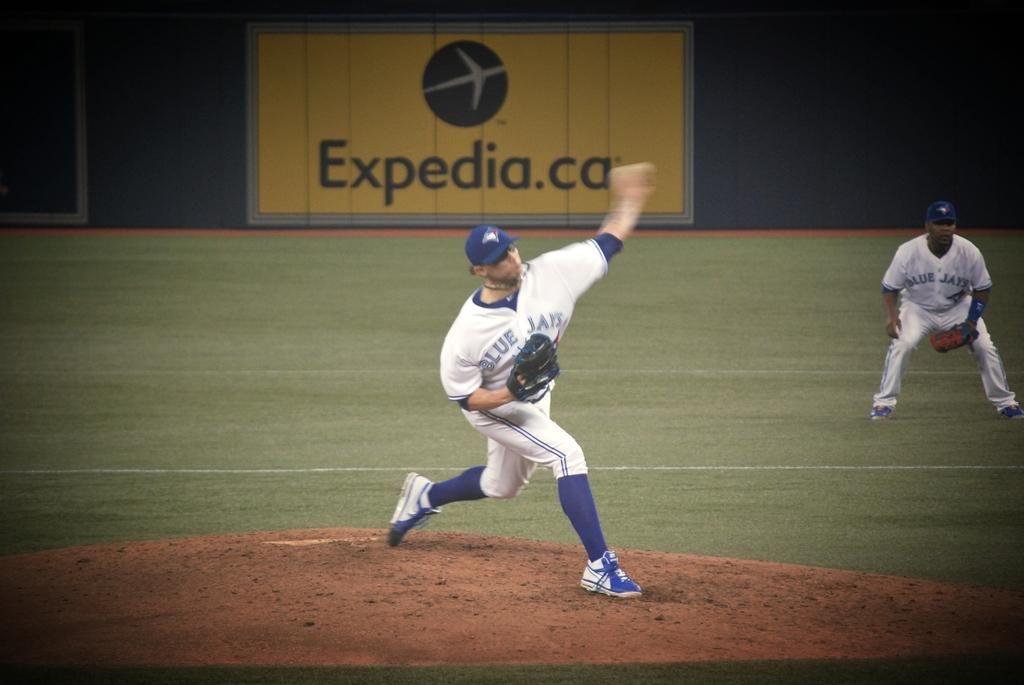<image>
Summarize the visual content of the image. A Blue Jays pitcher delivers a pitch at the mound. 